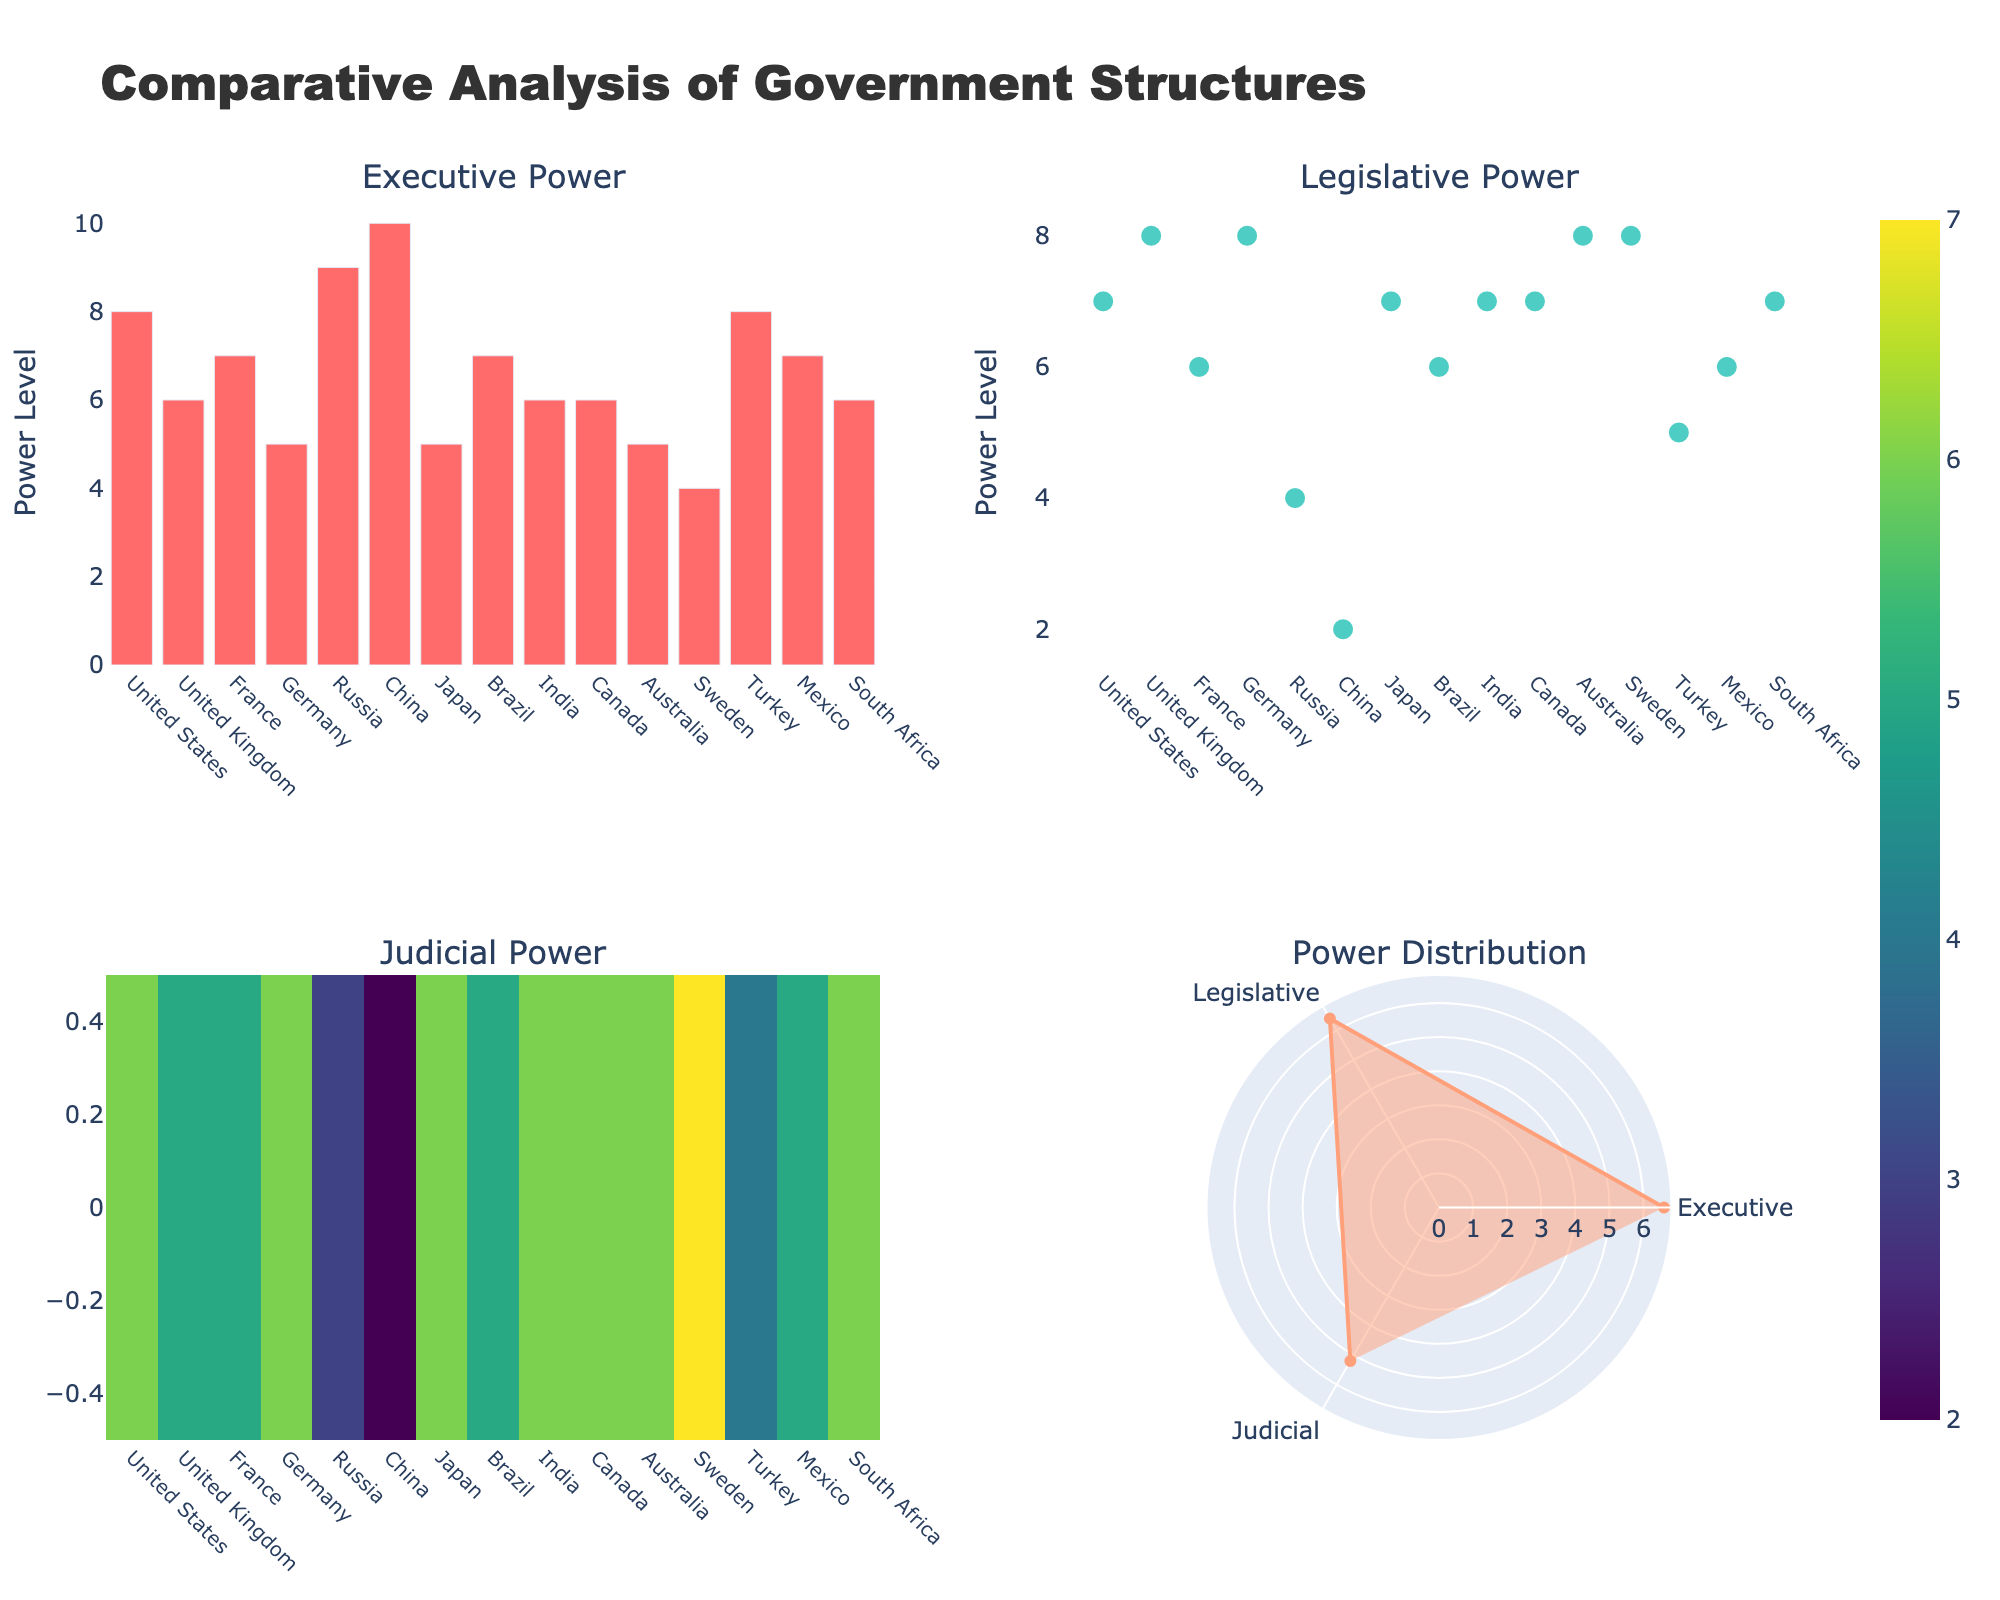what is the title of the plot? The title is displayed at the top center of the plot. It provides a summary of the entire figure.
Answer: Comparative Analysis of Government Structures How many countries have their judicial power shown on the heatmap? By counting the number of ticks on the X-axis of the heatmap subplot, we can determine the number of countries.
Answer: 15 what is the color used for the executive power bar chart? The color for the bars in the executive power chart can be observed visually.
Answer: Red Which country has the highest legislative power based on the scatter plot? By looking at the scatter plot, we can identify the country with the highest y-value for legislative power.
Answer: United Kingdom What is the average level of judicial power displayed in the polar chart? The average level of judicial power can be found directly on the polar chart where the 'Judicial' label aligns.
Answer: 5.3 Which country has the lowest judicial power according to the heatmap? By examining the color intensity in the heatmap, the country with the lowest value (darker color) can be found.
Answer: China When considering the executive power and legislative power, which country shows more balance in both powers? By comparing the bar heights and scatter plot points, we look for a country where the values are closest to each other.
Answer: Japan What is unique about China's governmental structure concerning power distribution as seen across the subplots? By observing the high executive power and significantly lower legislative and judicial powers across the plots, it can be inferred that China's power distribution is heavily weighted towards the executive power.
Answer: One-party dominance What is the combined power (sum of executive, legislative, and judicial) for Turkey? From the values given across the plots: Executive (8) + Legislative (5) + Judicial (4). The combined power can be calculated by summing these values.
Answer: 17 